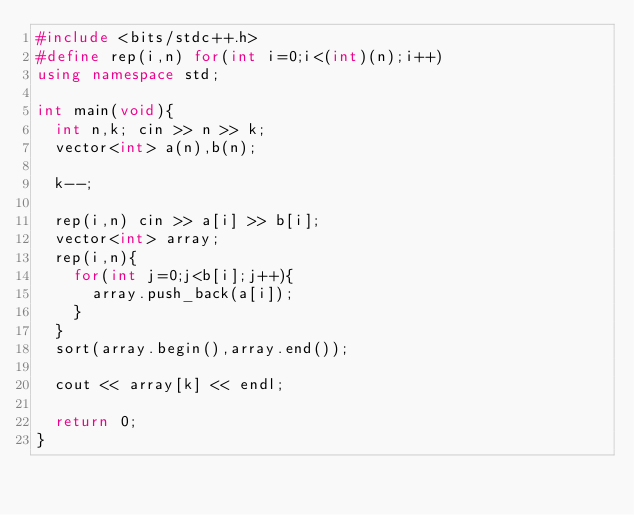Convert code to text. <code><loc_0><loc_0><loc_500><loc_500><_C++_>#include <bits/stdc++.h>
#define rep(i,n) for(int i=0;i<(int)(n);i++)
using namespace std;

int main(void){
  int n,k; cin >> n >> k;
  vector<int> a(n),b(n);

  k--;
  
  rep(i,n) cin >> a[i] >> b[i];
  vector<int> array;
  rep(i,n){
    for(int j=0;j<b[i];j++){
      array.push_back(a[i]);
    }
  }
  sort(array.begin(),array.end());
  
  cout << array[k] << endl;
  
  return 0;
}
</code> 